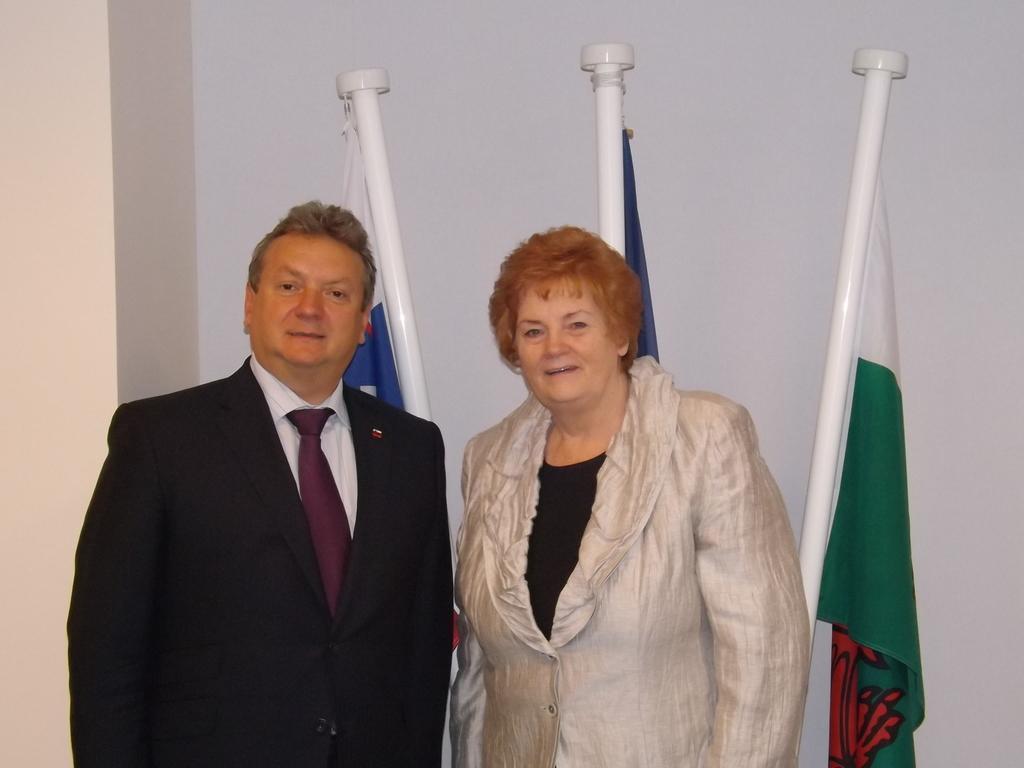Could you give a brief overview of what you see in this image? In this image we can see a man and a woman standing. In the background we can see the flags and also the wall. 